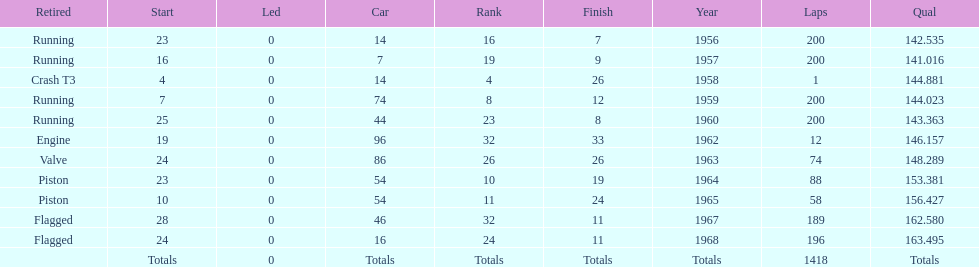Did bob veith drive more indy 500 laps in the 1950s or 1960s? 1960s. 